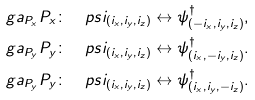Convert formula to latex. <formula><loc_0><loc_0><loc_500><loc_500>\ g a _ { P _ { x } } P _ { x } \colon & \quad p s i _ { ( i _ { x } , i _ { y } , i _ { z } ) } \leftrightarrow \psi ^ { \dag } _ { ( - i _ { x } , i _ { y } , i _ { z } ) } , \\ \ g a _ { P _ { y } } P _ { y } \colon & \quad p s i _ { ( i _ { x } , i _ { y } , i _ { z } ) } \leftrightarrow \psi ^ { \dag } _ { ( i _ { x } , - i _ { y } , i _ { z } ) } . \\ \ g a _ { P _ { y } } P _ { y } \colon & \quad p s i _ { ( i _ { x } , i _ { y } , i _ { z } ) } \leftrightarrow \psi ^ { \dag } _ { ( i _ { x } , i _ { y } , - i _ { z } ) } .</formula> 